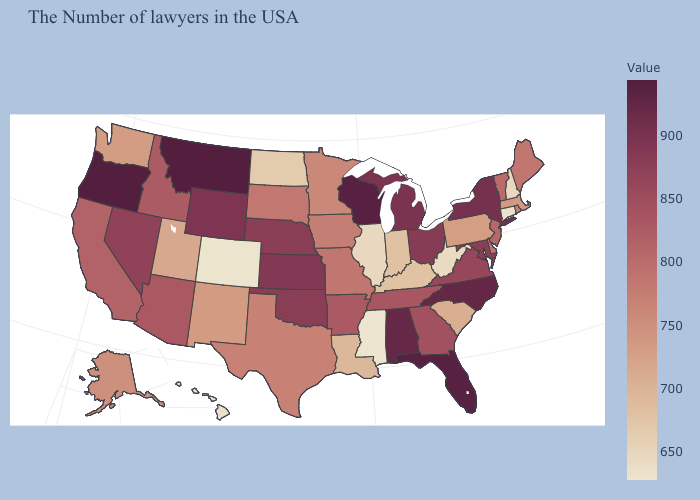Which states have the highest value in the USA?
Keep it brief. Montana, Oregon. Is the legend a continuous bar?
Quick response, please. Yes. Does the map have missing data?
Keep it brief. No. Does South Carolina have the lowest value in the South?
Concise answer only. No. 